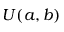Convert formula to latex. <formula><loc_0><loc_0><loc_500><loc_500>U ( a , b )</formula> 